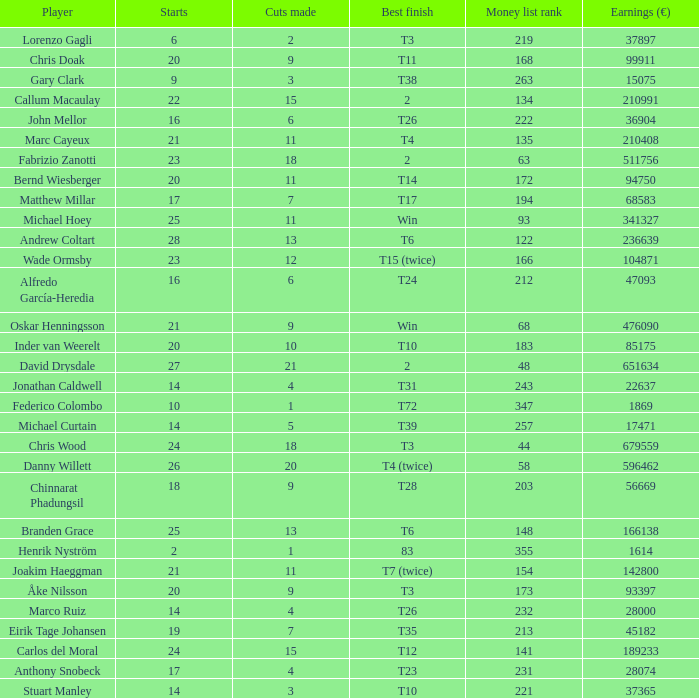How many cuts did Gary Clark make? 3.0. 